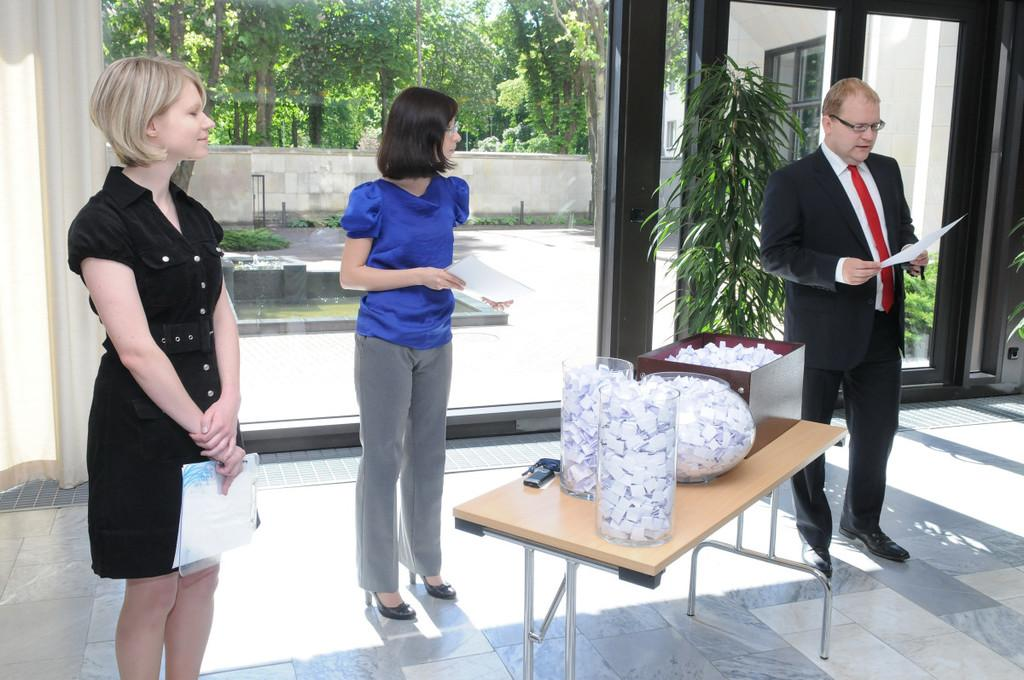How many girls are in the image? There are 2 girls standing in the middle of the image. Where is the man located in the image? The man is standing in the right side of the image. What is the man wearing? The man is wearing a coat and a tie. What can be seen behind the man? There is a plant visible behind the man. What type of soda is the man holding in the image? There is no soda present in the image; the man is not holding any beverage. Can you tell me how many pickles are on the plant behind the man? There are no pickles present in the image; the plant is not a vegetable garden. 